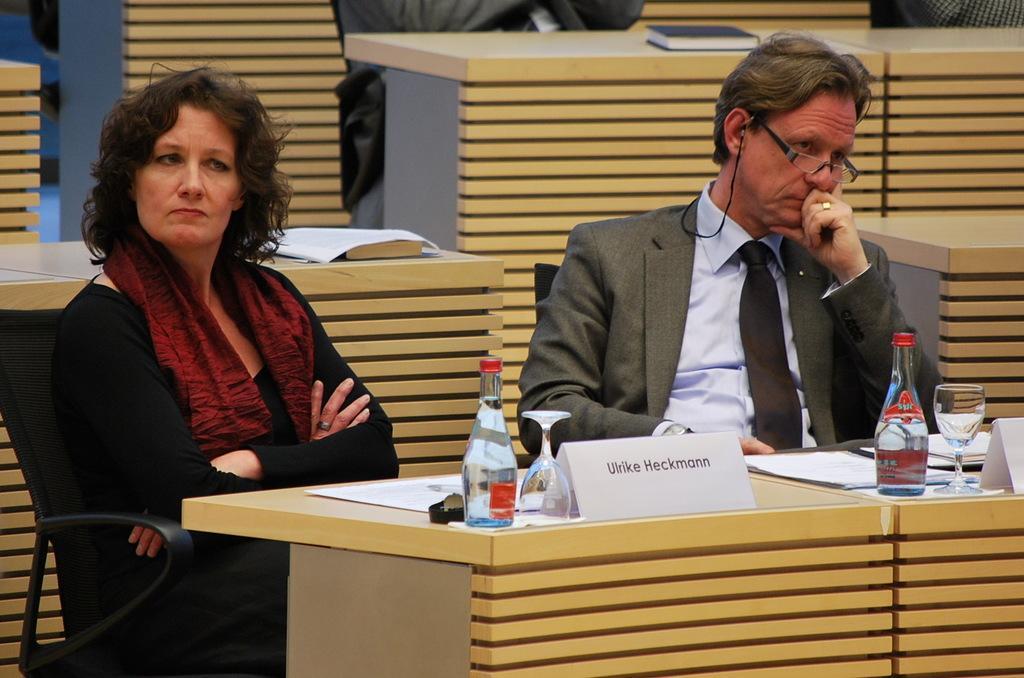Describe this image in one or two sentences. In the picture I can see two persons sitting in chairs and there is a table in front of them which has few papers and some other objects placed on it and there are few other persons and tables in the background. 